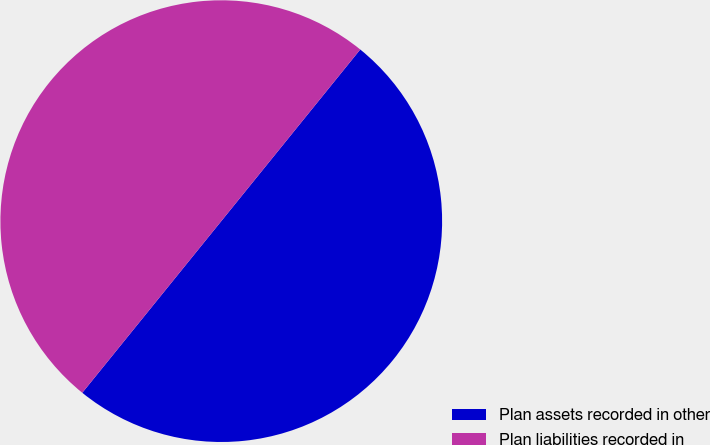Convert chart. <chart><loc_0><loc_0><loc_500><loc_500><pie_chart><fcel>Plan assets recorded in other<fcel>Plan liabilities recorded in<nl><fcel>50.0%<fcel>50.0%<nl></chart> 